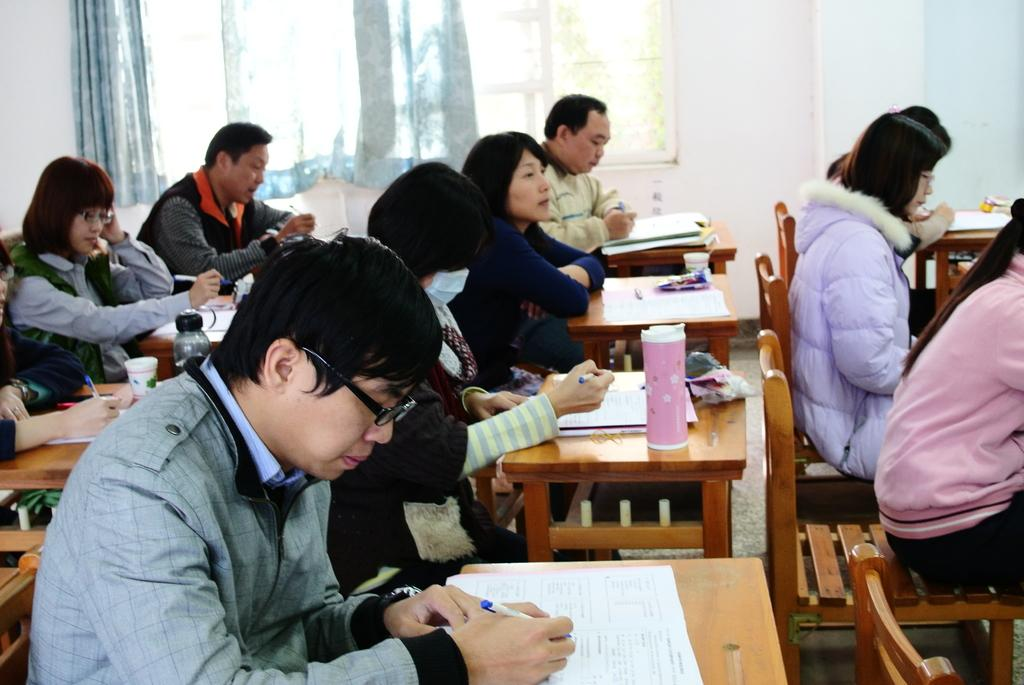How many people are in the image? There is a group of persons in the image. What are the persons doing in the image? The persons are sitting on benches and writing something. What type of tin can be seen in the image? There is no tin present in the image. What knowledge is being gained by the persons in the image? The provided facts do not indicate that the persons are gaining any knowledge; they are simply writing something. 